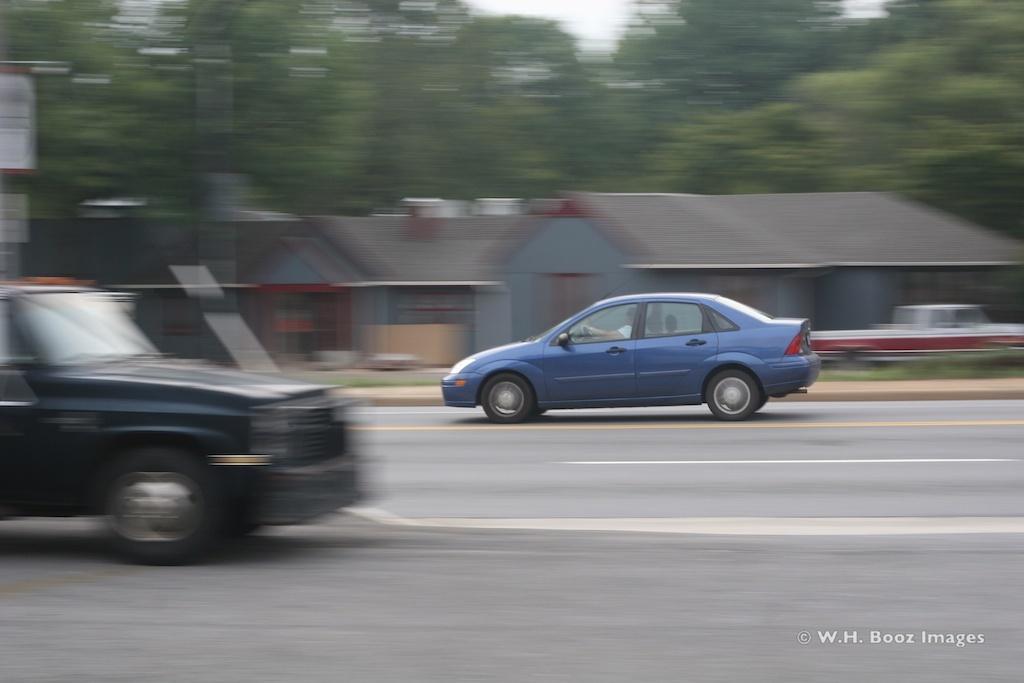Describe this image in one or two sentences. In this image in the center there are cars moving on the road. In the background there are houses and trees and there's grass on the ground. 